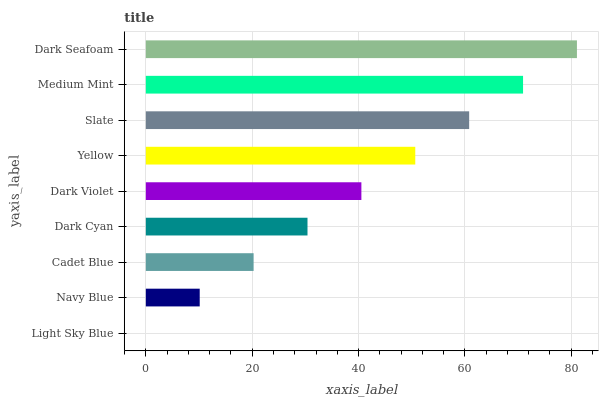Is Light Sky Blue the minimum?
Answer yes or no. Yes. Is Dark Seafoam the maximum?
Answer yes or no. Yes. Is Navy Blue the minimum?
Answer yes or no. No. Is Navy Blue the maximum?
Answer yes or no. No. Is Navy Blue greater than Light Sky Blue?
Answer yes or no. Yes. Is Light Sky Blue less than Navy Blue?
Answer yes or no. Yes. Is Light Sky Blue greater than Navy Blue?
Answer yes or no. No. Is Navy Blue less than Light Sky Blue?
Answer yes or no. No. Is Dark Violet the high median?
Answer yes or no. Yes. Is Dark Violet the low median?
Answer yes or no. Yes. Is Light Sky Blue the high median?
Answer yes or no. No. Is Slate the low median?
Answer yes or no. No. 